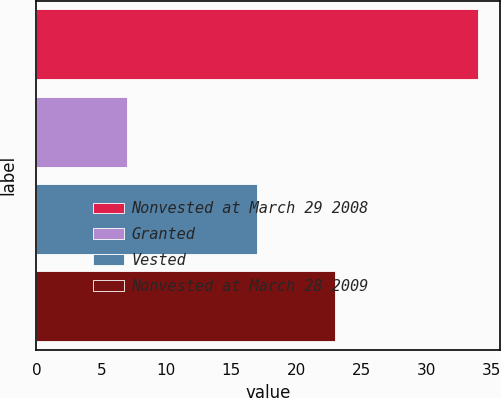<chart> <loc_0><loc_0><loc_500><loc_500><bar_chart><fcel>Nonvested at March 29 2008<fcel>Granted<fcel>Vested<fcel>Nonvested at March 28 2009<nl><fcel>34<fcel>7<fcel>17<fcel>23<nl></chart> 